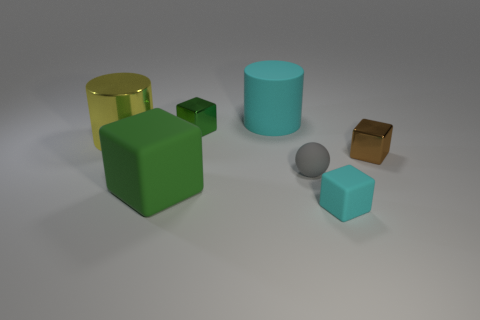There is a tiny thing that is both to the right of the gray sphere and left of the brown metallic cube; what shape is it?
Your response must be concise. Cube. What is the color of the cylinder that is left of the big matte cube?
Provide a short and direct response. Yellow. There is a rubber object that is both behind the green rubber object and in front of the large yellow shiny cylinder; what size is it?
Keep it short and to the point. Small. Are the brown thing and the cyan thing that is in front of the tiny sphere made of the same material?
Make the answer very short. No. What number of metallic objects have the same shape as the large green rubber object?
Give a very brief answer. 2. There is a tiny cube that is the same color as the large matte cube; what is its material?
Offer a very short reply. Metal. What number of yellow matte balls are there?
Give a very brief answer. 0. There is a tiny brown object; does it have the same shape as the big matte thing behind the brown metallic cube?
Your answer should be very brief. No. What number of things are large green objects or cyan things that are in front of the tiny green metallic block?
Make the answer very short. 2. What is the material of the small green object that is the same shape as the tiny brown object?
Provide a succinct answer. Metal. 